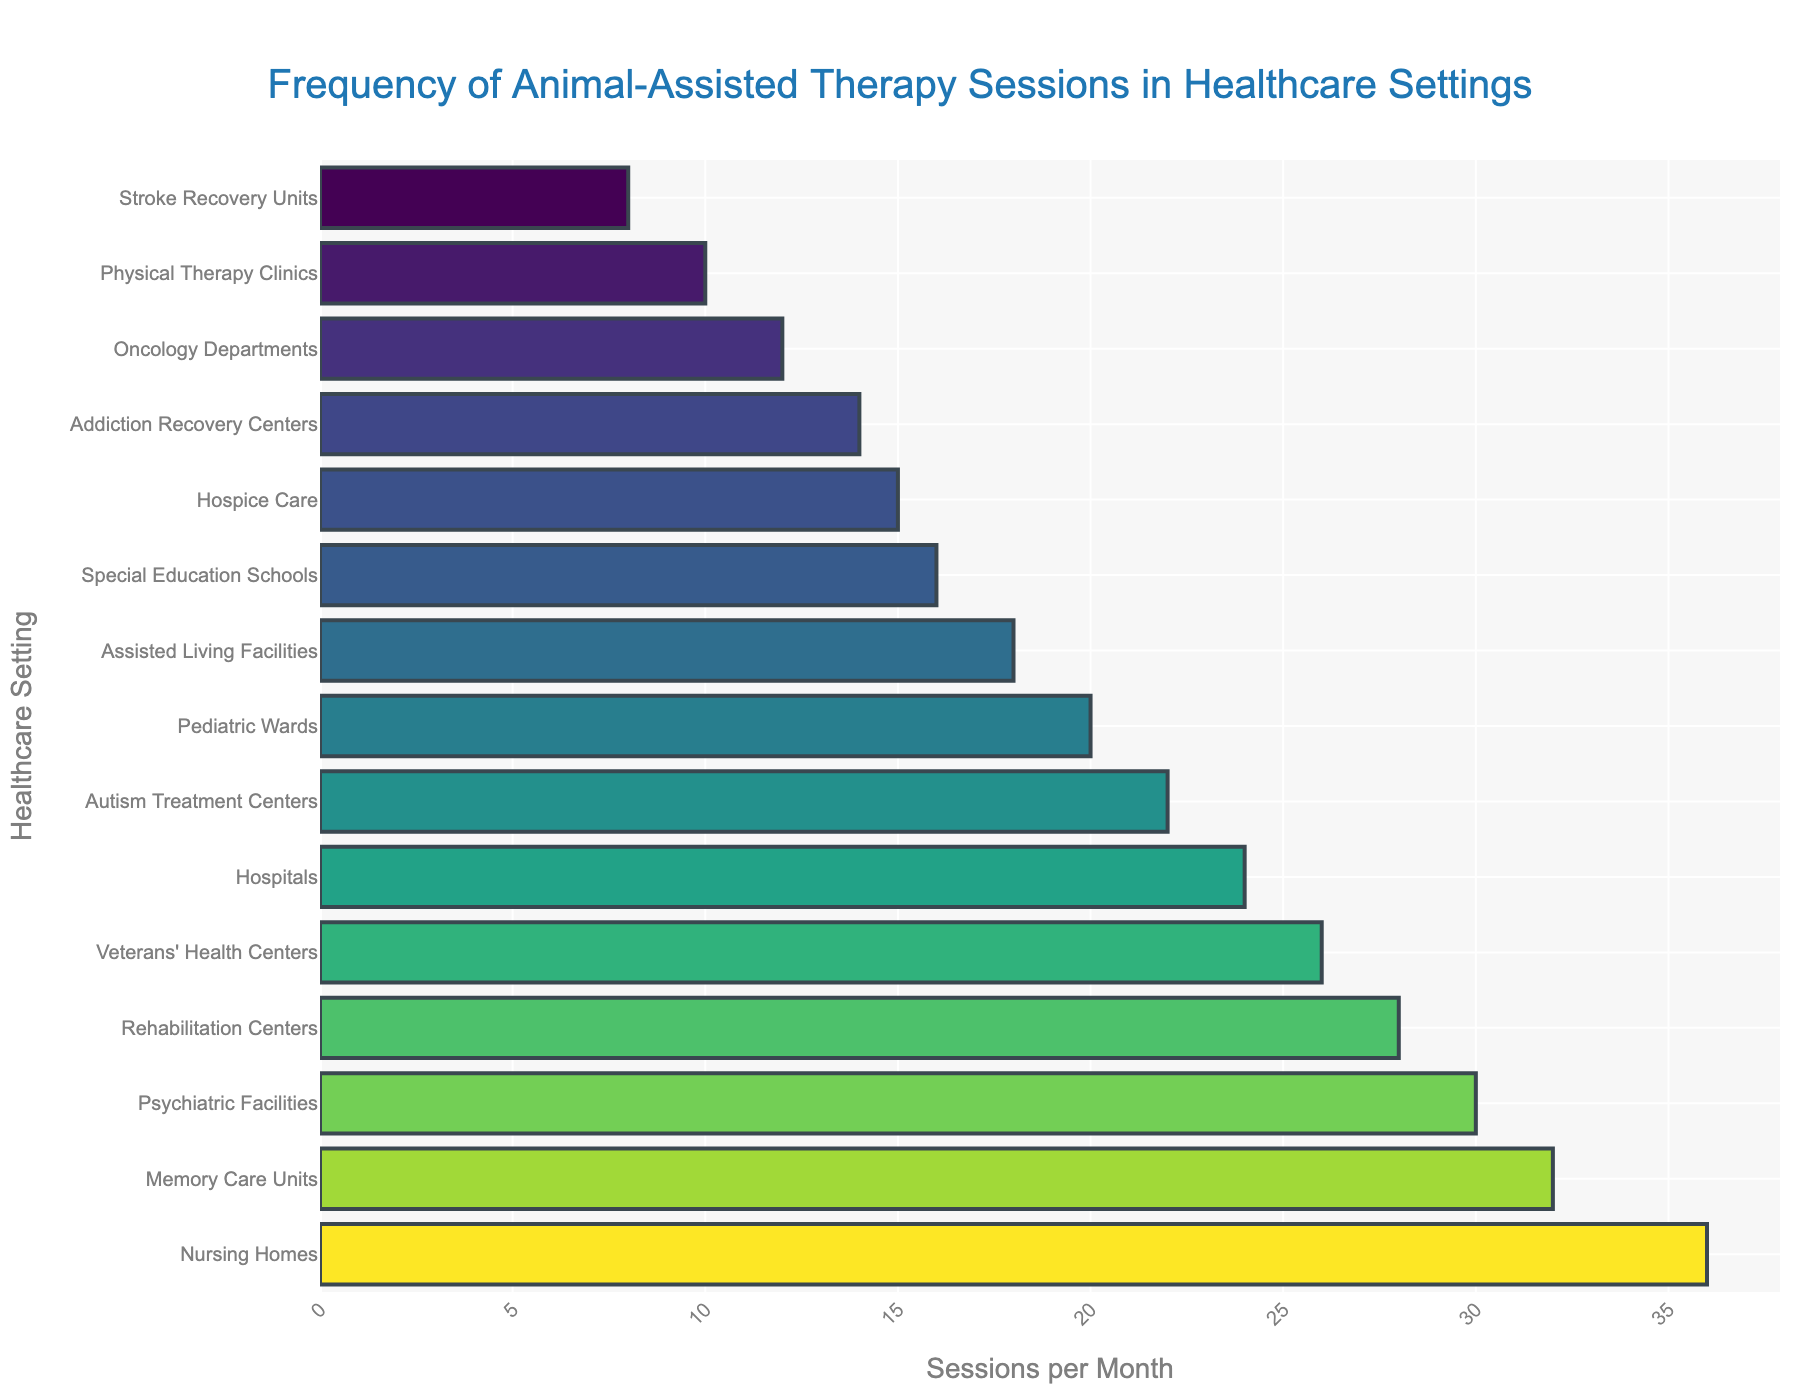What's the frequency of animal-assisted therapy sessions in nursing homes? The bar for nursing homes indicates that there are 36 sessions conducted per month.
Answer: 36 Which healthcare setting has the fewest animal-assisted therapy sessions? Out of all the bars, the Stroke Recovery Units have the shortest bar, which represents 8 sessions per month.
Answer: Stroke Recovery Units Which healthcare setting conducts more sessions: Pediatric Wards or Autism Treatment Centers? Pediatric Wards conduct 20 sessions per month, while Autism Treatment Centers conduct 22 sessions per month. 22 is greater than 20.
Answer: Autism Treatment Centers How many more sessions are conducted in Memory Care Units than in Addiction Recovery Centers? Memory Care Units have 32 sessions per month, and Addiction Recovery Centers have 14 sessions per month. The difference is 32 - 14 = 18.
Answer: 18 What’s the total number of sessions conducted in Hospitals, Veterans' Health Centers, and Oncology Departments combined? Hospitals conduct 24 sessions, Veterans' Health Centers conduct 26, and Oncology Departments conduct 12. The total number is 24 + 26 + 12 = 62.
Answer: 62 What’s the difference in the number of sessions between the most and least frequent settings? Nursing Homes are the most frequent with 36 sessions, and Stroke Recovery Units are the least with 8 sessions. The difference is 36 - 8 = 28.
Answer: 28 Which healthcare settings conduct fewer than 20 sessions per month? The settings with fewer than 20 sessions are Assisted Living Facilities (18), Hospice Care (15), Addiction Recovery Centers (14), Physical Therapy Clinics (10), Special Education Schools (16), Oncology Departments (12), and Stroke Recovery Units (8).
Answer: Assisted Living Facilities, Hospice Care, Addiction Recovery Centers, Physical Therapy Clinics, Special Education Schools, Oncology Departments, Stroke Recovery Units Comparing Psychiatric Facilities and Rehabilitation Centers, which conducts fewer sessions and by how much? Psychiatric Facilities conduct 30 sessions, and Rehabilitation Centers conduct 28 sessions. The difference is 30 - 28 = 2.
Answer: Rehabilitation Centers, 2 Which healthcare settings conduct more than 25 sessions per month? The settings with more than 25 sessions per month are Hospitals (24), Nursing Homes (36), Psychiatric Facilities (30), Rehabilitation Centers (28), and Veterans' Health Centers (26).
Answer: Nursing Homes, Psychiatric Facilities, Rehabilitation Centers, Memory Care Units What's the average number of sessions per month across all healthcare settings in the figure? Sum up all the sessions: 24 + 36 + 30 + 28 + 20 + 18 + 15 + 22 + 26 + 14 + 32 + 10 + 16 + 12 + 8 = 311. There are 15 settings. The average is 311 / 15 ≈ 20.73.
Answer: 20.73 